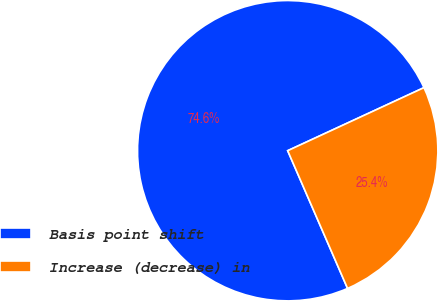Convert chart. <chart><loc_0><loc_0><loc_500><loc_500><pie_chart><fcel>Basis point shift<fcel>Increase (decrease) in<nl><fcel>74.63%<fcel>25.37%<nl></chart> 